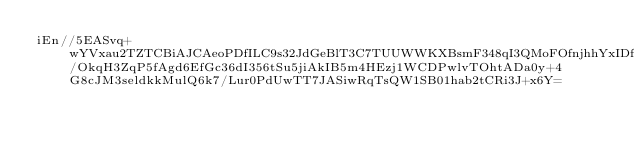Convert code to text. <code><loc_0><loc_0><loc_500><loc_500><_SML_>iEn//5EASvq+wYVxau2TZTCBiAJCAeoPDfILC9s32JdGeBlT3C7TUUWWKXBsmF348qI3QMoFOfnjhhYxIDf2/OkqH3ZqP5fAgd6EfGc36dI356tSu5jiAkIB5m4HEzj1WCDPwlvTOhtADa0y+4G8cJM3seldkkMulQ6k7/Lur0PdUwTT7JASiwRqTsQW1SB01hab2tCRi3J+x6Y=</code> 